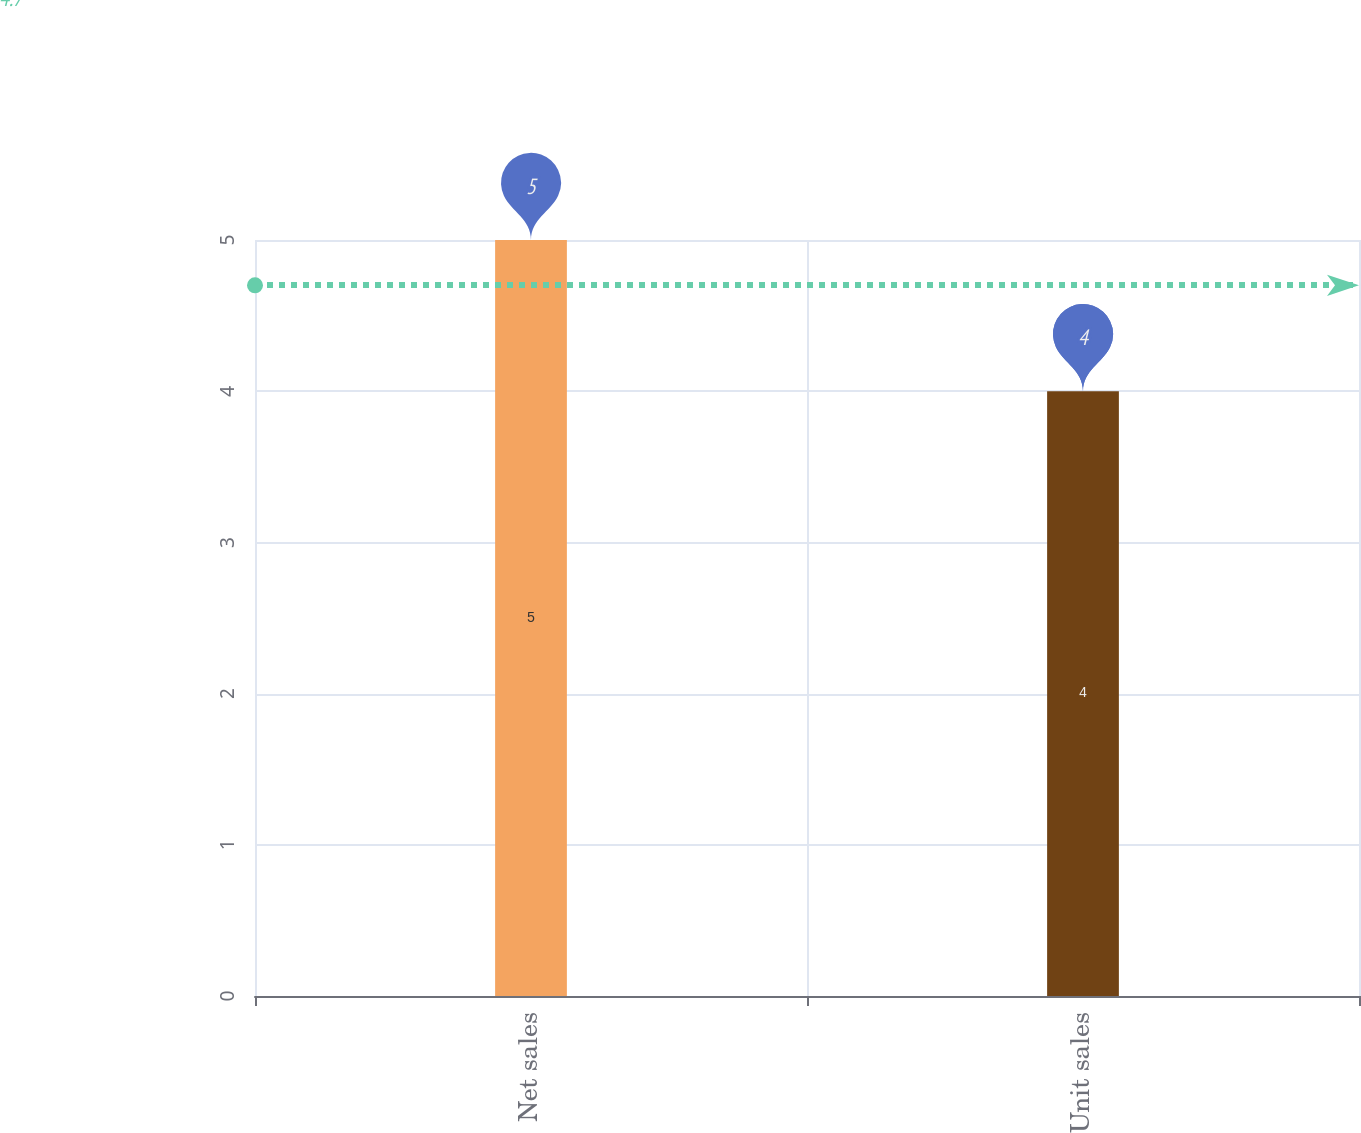<chart> <loc_0><loc_0><loc_500><loc_500><bar_chart><fcel>Net sales<fcel>Unit sales<nl><fcel>5<fcel>4<nl></chart> 